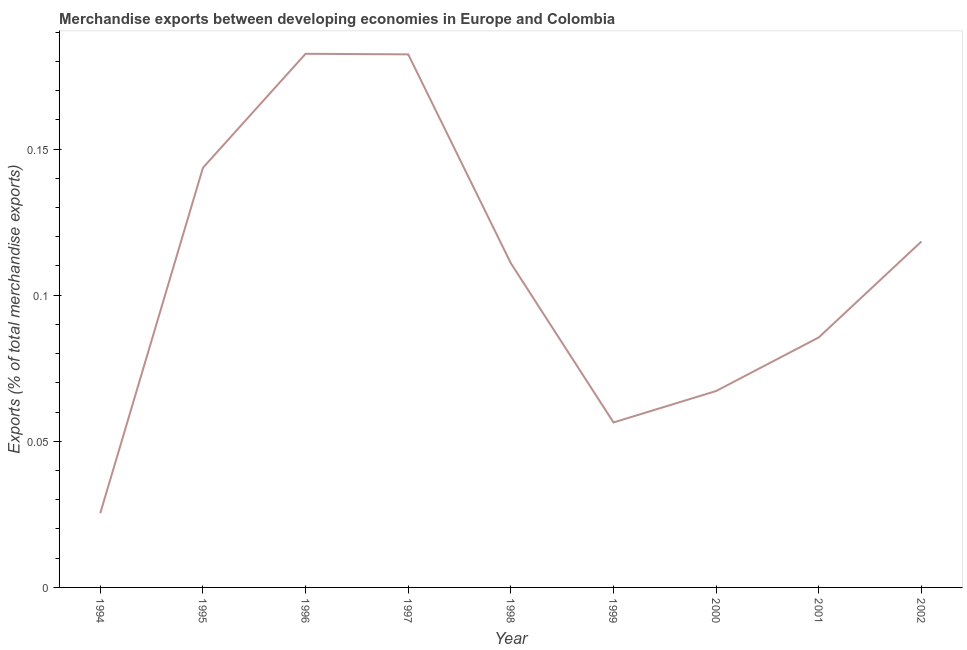What is the merchandise exports in 2001?
Keep it short and to the point. 0.09. Across all years, what is the maximum merchandise exports?
Provide a short and direct response. 0.18. Across all years, what is the minimum merchandise exports?
Your response must be concise. 0.03. In which year was the merchandise exports minimum?
Give a very brief answer. 1994. What is the sum of the merchandise exports?
Keep it short and to the point. 0.97. What is the difference between the merchandise exports in 1994 and 2001?
Offer a very short reply. -0.06. What is the average merchandise exports per year?
Offer a very short reply. 0.11. What is the median merchandise exports?
Give a very brief answer. 0.11. Do a majority of the years between 1997 and 2002 (inclusive) have merchandise exports greater than 0.15000000000000002 %?
Offer a very short reply. No. What is the ratio of the merchandise exports in 1997 to that in 2000?
Provide a short and direct response. 2.71. Is the merchandise exports in 1997 less than that in 2002?
Provide a succinct answer. No. What is the difference between the highest and the second highest merchandise exports?
Offer a very short reply. 0. Is the sum of the merchandise exports in 1994 and 2002 greater than the maximum merchandise exports across all years?
Provide a short and direct response. No. What is the difference between the highest and the lowest merchandise exports?
Ensure brevity in your answer.  0.16. Does the merchandise exports monotonically increase over the years?
Your answer should be compact. No. How many lines are there?
Keep it short and to the point. 1. Are the values on the major ticks of Y-axis written in scientific E-notation?
Provide a succinct answer. No. Does the graph contain any zero values?
Provide a succinct answer. No. Does the graph contain grids?
Offer a terse response. No. What is the title of the graph?
Your answer should be very brief. Merchandise exports between developing economies in Europe and Colombia. What is the label or title of the Y-axis?
Your answer should be very brief. Exports (% of total merchandise exports). What is the Exports (% of total merchandise exports) in 1994?
Your response must be concise. 0.03. What is the Exports (% of total merchandise exports) of 1995?
Offer a terse response. 0.14. What is the Exports (% of total merchandise exports) of 1996?
Offer a terse response. 0.18. What is the Exports (% of total merchandise exports) of 1997?
Provide a short and direct response. 0.18. What is the Exports (% of total merchandise exports) of 1998?
Your answer should be compact. 0.11. What is the Exports (% of total merchandise exports) of 1999?
Keep it short and to the point. 0.06. What is the Exports (% of total merchandise exports) in 2000?
Ensure brevity in your answer.  0.07. What is the Exports (% of total merchandise exports) in 2001?
Keep it short and to the point. 0.09. What is the Exports (% of total merchandise exports) in 2002?
Give a very brief answer. 0.12. What is the difference between the Exports (% of total merchandise exports) in 1994 and 1995?
Provide a succinct answer. -0.12. What is the difference between the Exports (% of total merchandise exports) in 1994 and 1996?
Give a very brief answer. -0.16. What is the difference between the Exports (% of total merchandise exports) in 1994 and 1997?
Make the answer very short. -0.16. What is the difference between the Exports (% of total merchandise exports) in 1994 and 1998?
Make the answer very short. -0.09. What is the difference between the Exports (% of total merchandise exports) in 1994 and 1999?
Your answer should be compact. -0.03. What is the difference between the Exports (% of total merchandise exports) in 1994 and 2000?
Your response must be concise. -0.04. What is the difference between the Exports (% of total merchandise exports) in 1994 and 2001?
Ensure brevity in your answer.  -0.06. What is the difference between the Exports (% of total merchandise exports) in 1994 and 2002?
Give a very brief answer. -0.09. What is the difference between the Exports (% of total merchandise exports) in 1995 and 1996?
Ensure brevity in your answer.  -0.04. What is the difference between the Exports (% of total merchandise exports) in 1995 and 1997?
Keep it short and to the point. -0.04. What is the difference between the Exports (% of total merchandise exports) in 1995 and 1998?
Give a very brief answer. 0.03. What is the difference between the Exports (% of total merchandise exports) in 1995 and 1999?
Ensure brevity in your answer.  0.09. What is the difference between the Exports (% of total merchandise exports) in 1995 and 2000?
Your answer should be very brief. 0.08. What is the difference between the Exports (% of total merchandise exports) in 1995 and 2001?
Keep it short and to the point. 0.06. What is the difference between the Exports (% of total merchandise exports) in 1995 and 2002?
Your answer should be compact. 0.03. What is the difference between the Exports (% of total merchandise exports) in 1996 and 1997?
Offer a very short reply. 0. What is the difference between the Exports (% of total merchandise exports) in 1996 and 1998?
Provide a short and direct response. 0.07. What is the difference between the Exports (% of total merchandise exports) in 1996 and 1999?
Offer a very short reply. 0.13. What is the difference between the Exports (% of total merchandise exports) in 1996 and 2000?
Give a very brief answer. 0.12. What is the difference between the Exports (% of total merchandise exports) in 1996 and 2001?
Make the answer very short. 0.1. What is the difference between the Exports (% of total merchandise exports) in 1996 and 2002?
Keep it short and to the point. 0.06. What is the difference between the Exports (% of total merchandise exports) in 1997 and 1998?
Give a very brief answer. 0.07. What is the difference between the Exports (% of total merchandise exports) in 1997 and 1999?
Your answer should be compact. 0.13. What is the difference between the Exports (% of total merchandise exports) in 1997 and 2000?
Offer a terse response. 0.12. What is the difference between the Exports (% of total merchandise exports) in 1997 and 2001?
Your response must be concise. 0.1. What is the difference between the Exports (% of total merchandise exports) in 1997 and 2002?
Your answer should be very brief. 0.06. What is the difference between the Exports (% of total merchandise exports) in 1998 and 1999?
Provide a short and direct response. 0.05. What is the difference between the Exports (% of total merchandise exports) in 1998 and 2000?
Offer a very short reply. 0.04. What is the difference between the Exports (% of total merchandise exports) in 1998 and 2001?
Provide a succinct answer. 0.03. What is the difference between the Exports (% of total merchandise exports) in 1998 and 2002?
Give a very brief answer. -0.01. What is the difference between the Exports (% of total merchandise exports) in 1999 and 2000?
Provide a succinct answer. -0.01. What is the difference between the Exports (% of total merchandise exports) in 1999 and 2001?
Make the answer very short. -0.03. What is the difference between the Exports (% of total merchandise exports) in 1999 and 2002?
Make the answer very short. -0.06. What is the difference between the Exports (% of total merchandise exports) in 2000 and 2001?
Offer a very short reply. -0.02. What is the difference between the Exports (% of total merchandise exports) in 2000 and 2002?
Provide a succinct answer. -0.05. What is the difference between the Exports (% of total merchandise exports) in 2001 and 2002?
Your response must be concise. -0.03. What is the ratio of the Exports (% of total merchandise exports) in 1994 to that in 1995?
Provide a succinct answer. 0.18. What is the ratio of the Exports (% of total merchandise exports) in 1994 to that in 1996?
Make the answer very short. 0.14. What is the ratio of the Exports (% of total merchandise exports) in 1994 to that in 1997?
Your answer should be compact. 0.14. What is the ratio of the Exports (% of total merchandise exports) in 1994 to that in 1998?
Your response must be concise. 0.23. What is the ratio of the Exports (% of total merchandise exports) in 1994 to that in 1999?
Your response must be concise. 0.45. What is the ratio of the Exports (% of total merchandise exports) in 1994 to that in 2000?
Your answer should be very brief. 0.38. What is the ratio of the Exports (% of total merchandise exports) in 1994 to that in 2001?
Offer a very short reply. 0.3. What is the ratio of the Exports (% of total merchandise exports) in 1994 to that in 2002?
Keep it short and to the point. 0.21. What is the ratio of the Exports (% of total merchandise exports) in 1995 to that in 1996?
Offer a very short reply. 0.79. What is the ratio of the Exports (% of total merchandise exports) in 1995 to that in 1997?
Your answer should be very brief. 0.79. What is the ratio of the Exports (% of total merchandise exports) in 1995 to that in 1998?
Give a very brief answer. 1.29. What is the ratio of the Exports (% of total merchandise exports) in 1995 to that in 1999?
Make the answer very short. 2.54. What is the ratio of the Exports (% of total merchandise exports) in 1995 to that in 2000?
Make the answer very short. 2.14. What is the ratio of the Exports (% of total merchandise exports) in 1995 to that in 2001?
Your answer should be very brief. 1.68. What is the ratio of the Exports (% of total merchandise exports) in 1995 to that in 2002?
Your answer should be compact. 1.21. What is the ratio of the Exports (% of total merchandise exports) in 1996 to that in 1998?
Ensure brevity in your answer.  1.65. What is the ratio of the Exports (% of total merchandise exports) in 1996 to that in 1999?
Give a very brief answer. 3.23. What is the ratio of the Exports (% of total merchandise exports) in 1996 to that in 2000?
Keep it short and to the point. 2.72. What is the ratio of the Exports (% of total merchandise exports) in 1996 to that in 2001?
Provide a succinct answer. 2.13. What is the ratio of the Exports (% of total merchandise exports) in 1996 to that in 2002?
Keep it short and to the point. 1.54. What is the ratio of the Exports (% of total merchandise exports) in 1997 to that in 1998?
Give a very brief answer. 1.64. What is the ratio of the Exports (% of total merchandise exports) in 1997 to that in 1999?
Offer a terse response. 3.23. What is the ratio of the Exports (% of total merchandise exports) in 1997 to that in 2000?
Your response must be concise. 2.71. What is the ratio of the Exports (% of total merchandise exports) in 1997 to that in 2001?
Your answer should be compact. 2.13. What is the ratio of the Exports (% of total merchandise exports) in 1997 to that in 2002?
Keep it short and to the point. 1.54. What is the ratio of the Exports (% of total merchandise exports) in 1998 to that in 1999?
Keep it short and to the point. 1.97. What is the ratio of the Exports (% of total merchandise exports) in 1998 to that in 2000?
Ensure brevity in your answer.  1.65. What is the ratio of the Exports (% of total merchandise exports) in 1998 to that in 2001?
Provide a succinct answer. 1.3. What is the ratio of the Exports (% of total merchandise exports) in 1998 to that in 2002?
Make the answer very short. 0.94. What is the ratio of the Exports (% of total merchandise exports) in 1999 to that in 2000?
Keep it short and to the point. 0.84. What is the ratio of the Exports (% of total merchandise exports) in 1999 to that in 2001?
Provide a short and direct response. 0.66. What is the ratio of the Exports (% of total merchandise exports) in 1999 to that in 2002?
Your answer should be very brief. 0.48. What is the ratio of the Exports (% of total merchandise exports) in 2000 to that in 2001?
Keep it short and to the point. 0.79. What is the ratio of the Exports (% of total merchandise exports) in 2000 to that in 2002?
Your response must be concise. 0.57. What is the ratio of the Exports (% of total merchandise exports) in 2001 to that in 2002?
Offer a terse response. 0.72. 